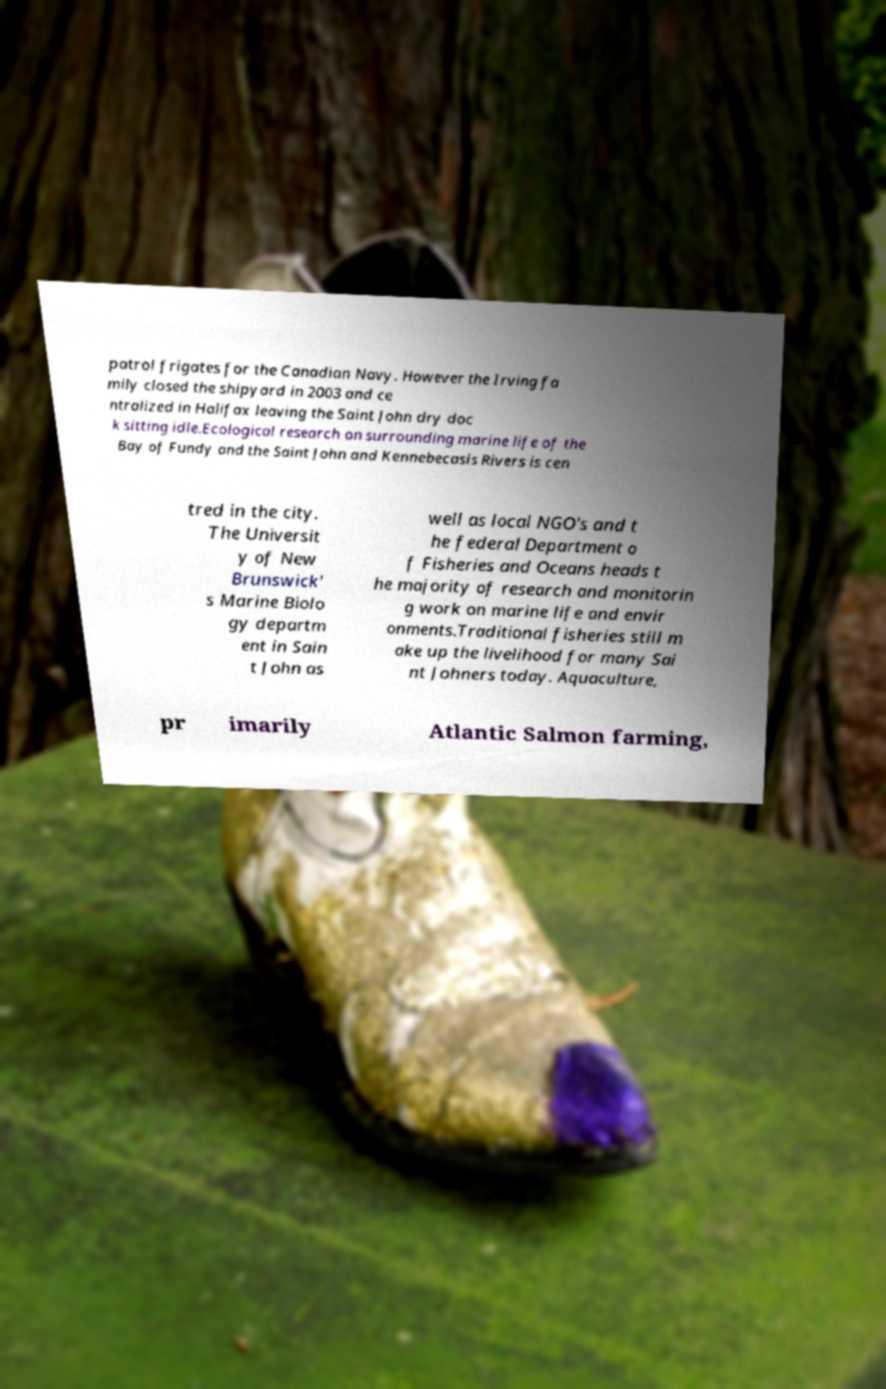What messages or text are displayed in this image? I need them in a readable, typed format. patrol frigates for the Canadian Navy. However the Irving fa mily closed the shipyard in 2003 and ce ntralized in Halifax leaving the Saint John dry doc k sitting idle.Ecological research on surrounding marine life of the Bay of Fundy and the Saint John and Kennebecasis Rivers is cen tred in the city. The Universit y of New Brunswick' s Marine Biolo gy departm ent in Sain t John as well as local NGO's and t he federal Department o f Fisheries and Oceans heads t he majority of research and monitorin g work on marine life and envir onments.Traditional fisheries still m ake up the livelihood for many Sai nt Johners today. Aquaculture, pr imarily Atlantic Salmon farming, 